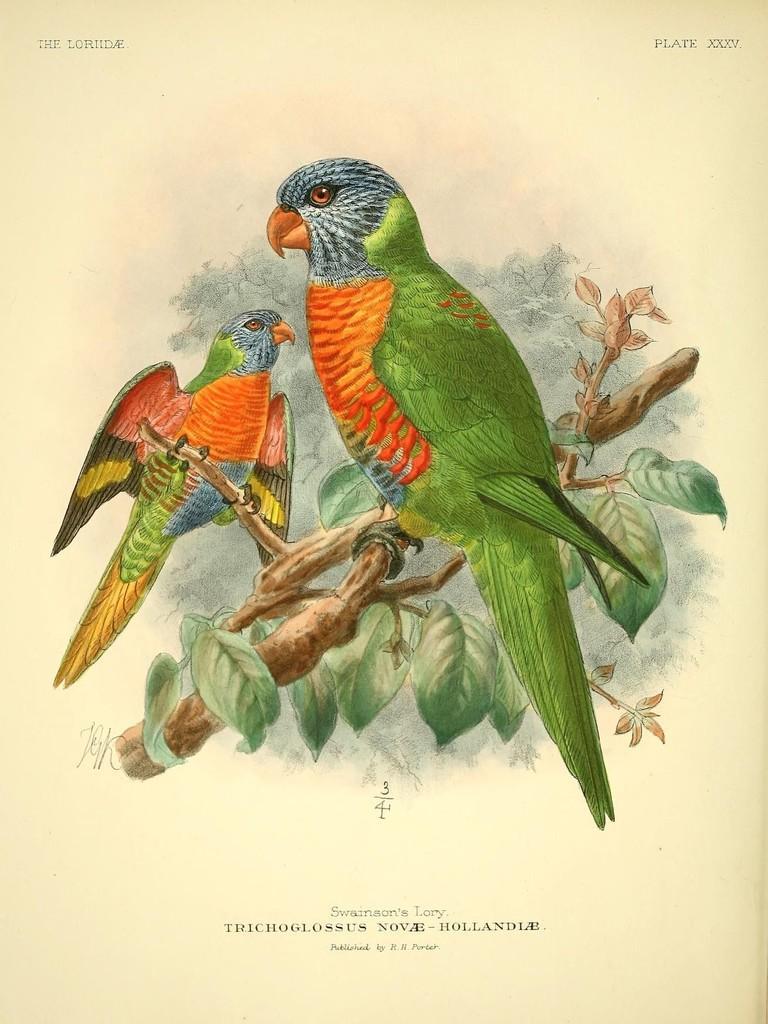Describe this image in one or two sentences. In this picture we can see a poster,on this poster we can see parrots on tree branches,here we can see some text. 